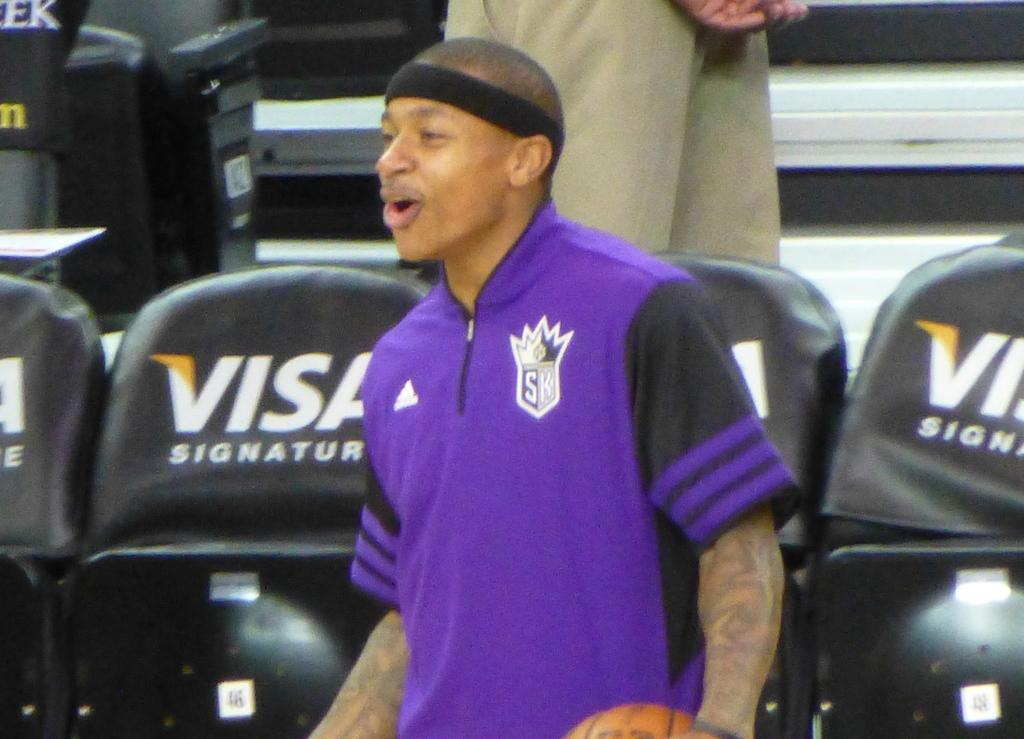<image>
Give a short and clear explanation of the subsequent image. A person wearing a purple shirt with an SK logo on it stands in front of seats with ads for Visa. 